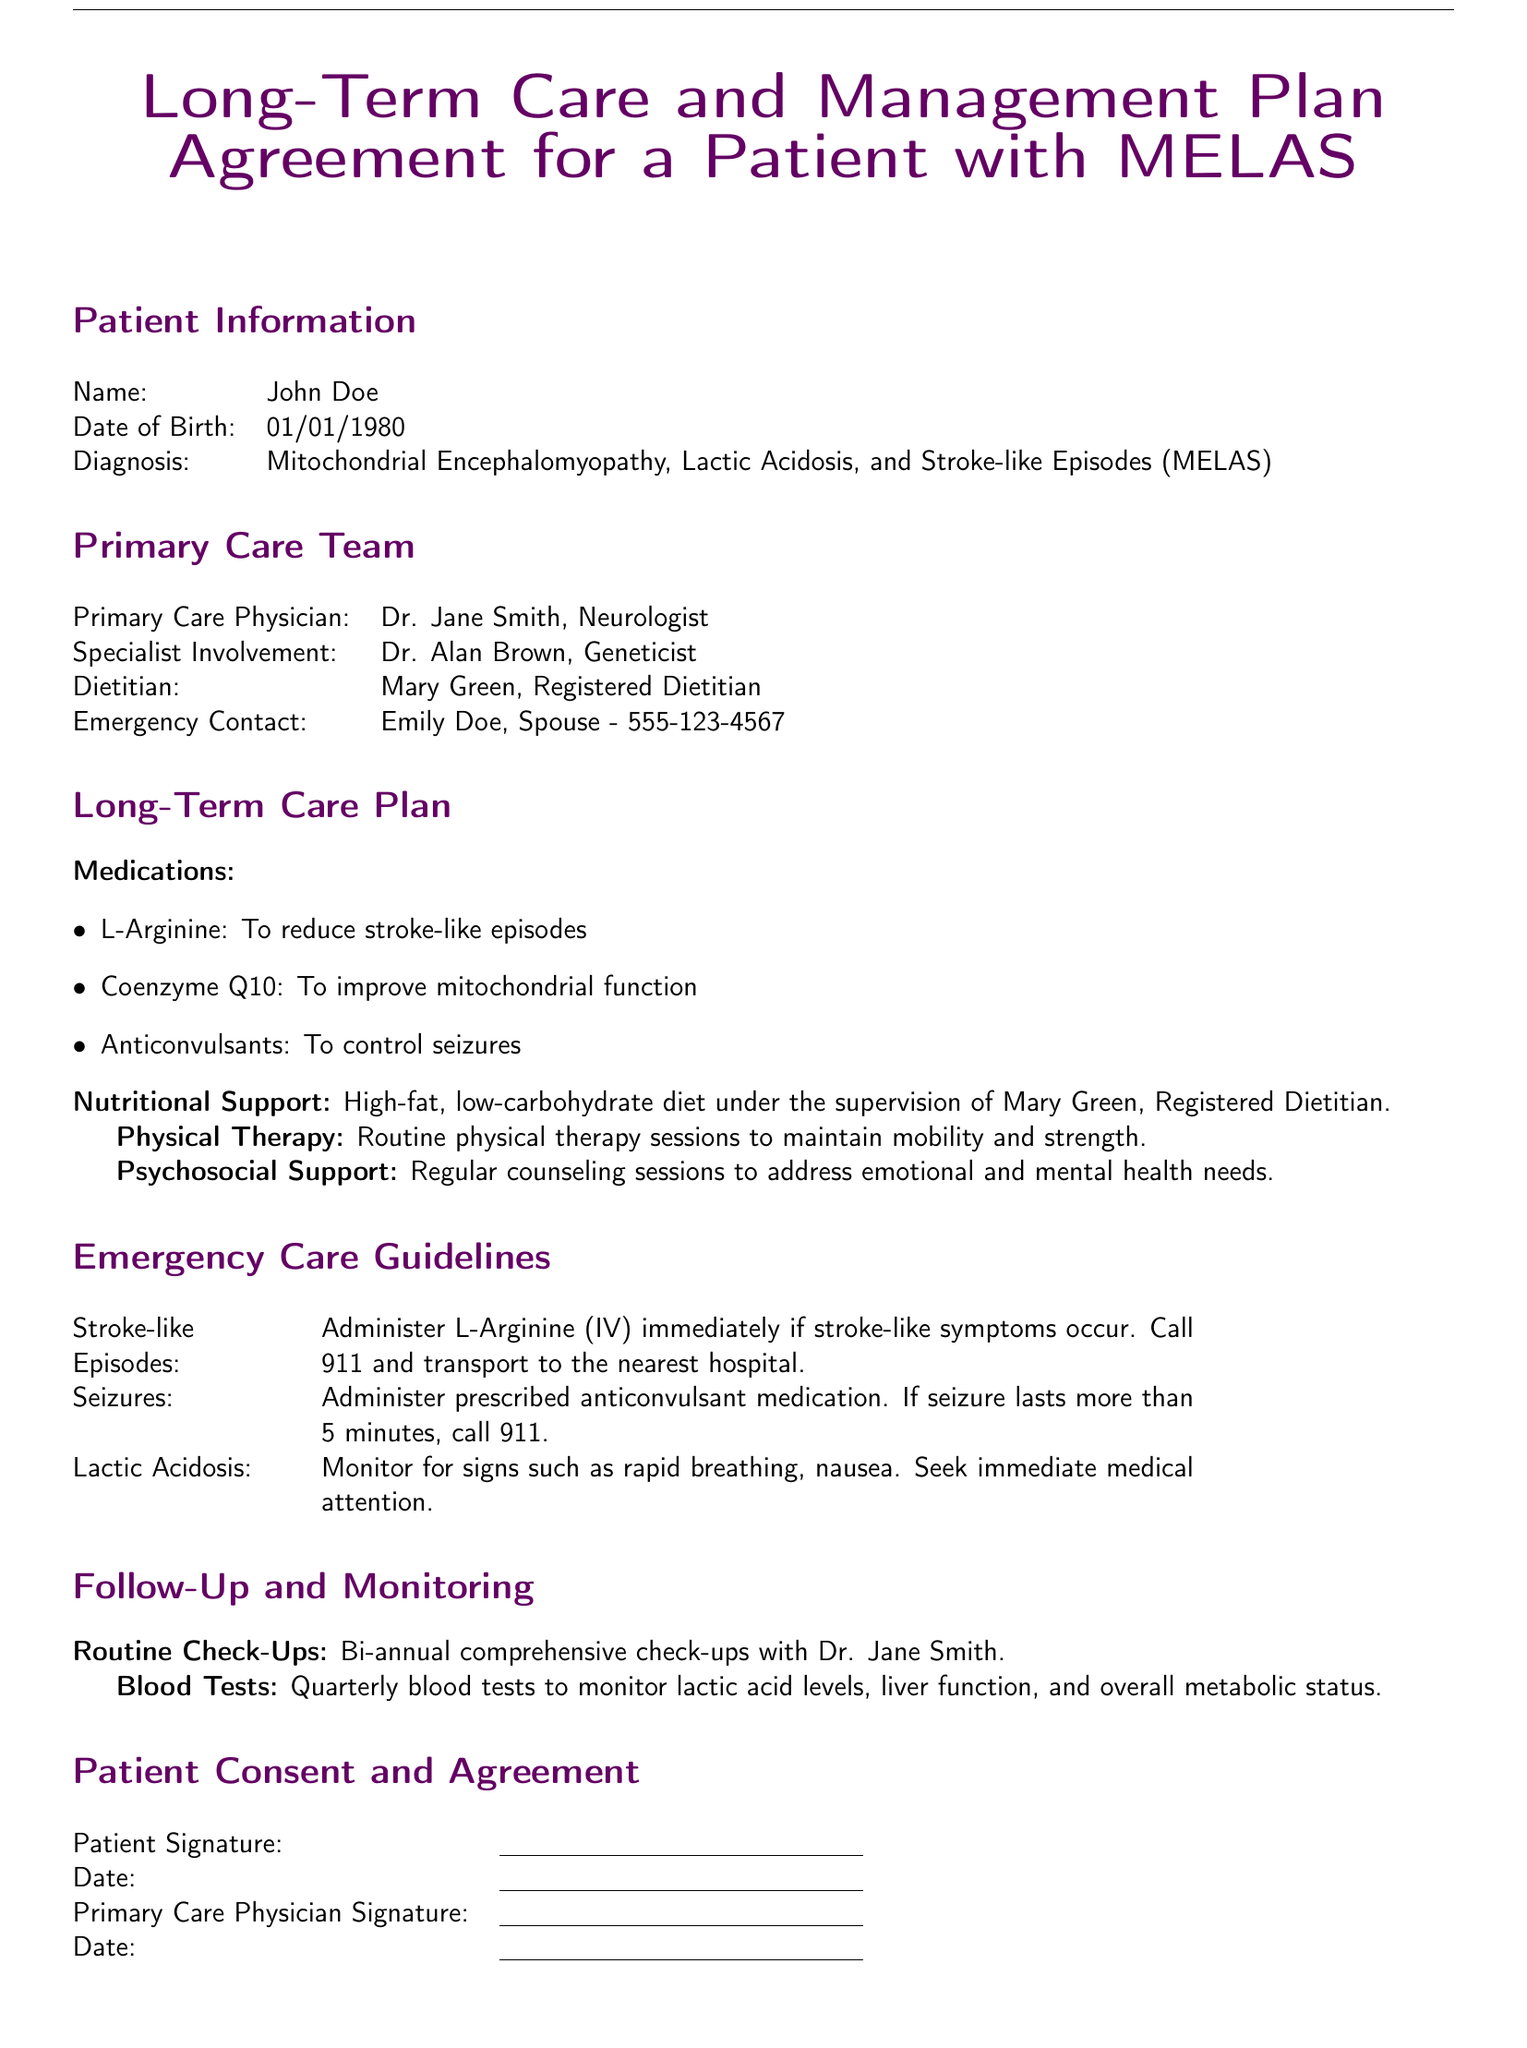What is the patient's name? The patient's name is listed in the Patient Information section of the document.
Answer: John Doe Who is the primary care physician? The primary care physician is mentioned in the Primary Care Team section of the document.
Answer: Dr. Jane Smith What medication is suggested to reduce stroke-like episodes? The medications are outlined in the Long-Term Care Plan section, specifying their purpose.
Answer: L-Arginine How often should the patient have routine check-ups? The frequency of routine check-ups is specified in the Follow-Up and Monitoring section.
Answer: Bi-annual What should be administered immediately if stroke-like symptoms occur? The Emergency Care Guidelines clearly state what to do in case of stroke-like episodes.
Answer: L-Arginine (IV) If a seizure lasts more than how many minutes should 911 be called? The document mentions this specific duration in the Emergency Care Guidelines.
Answer: 5 minutes Who provides nutritional support for the patient? The document identifies who is responsible for nutritional support in the Long-Term Care Plan section.
Answer: Mary Green What is the diagnostic condition of the patient? The diagnosis is provided in the Patient Information section of the document.
Answer: MELAS What is the objective of physical therapy mentioned in the plan? The Long-Term Care Plan outlines the purpose of physical therapy sessions.
Answer: Maintain mobility and strength 